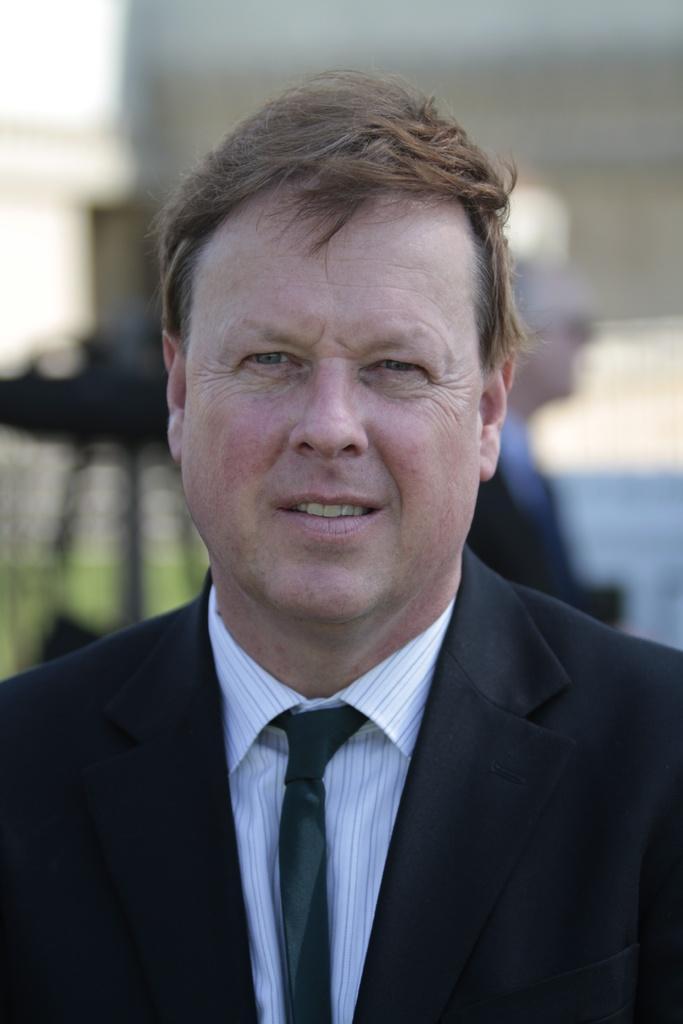Could you give a brief overview of what you see in this image? In this image I can see a person wearing black blazer, white shirt and black color tie. Background I can see the other person and the wall is in white color. 